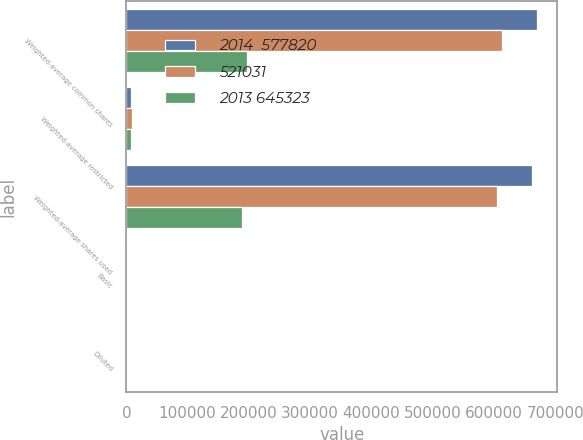Convert chart to OTSL. <chart><loc_0><loc_0><loc_500><loc_500><stacked_bar_chart><ecel><fcel>Weighted-average common shares<fcel>Weighted-average restricted<fcel>Weighted-average shares used<fcel>Basic<fcel>Diluted<nl><fcel>2014  577820<fcel>670132<fcel>7708<fcel>662424<fcel>0.79<fcel>0.79<nl><fcel>521031<fcel>613944<fcel>8954<fcel>604990<fcel>0.96<fcel>0.96<nl><fcel>2013 645323<fcel>196675<fcel>7165<fcel>189510<fcel>3.41<fcel>3.41<nl></chart> 